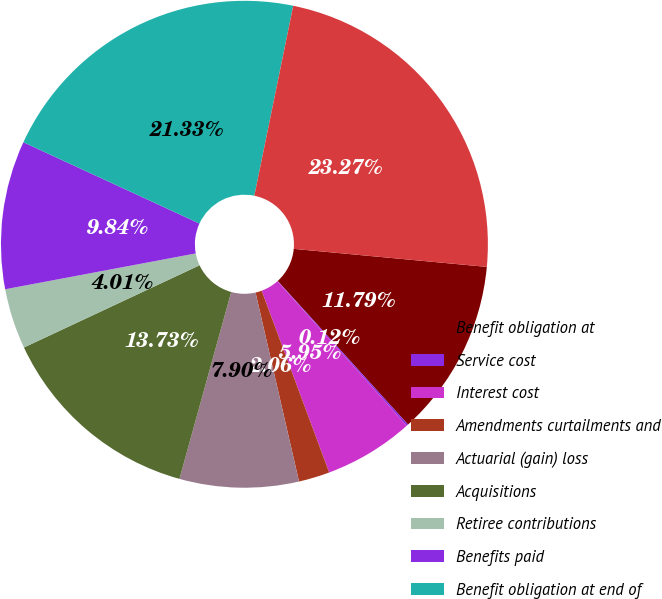Convert chart to OTSL. <chart><loc_0><loc_0><loc_500><loc_500><pie_chart><fcel>Benefit obligation at<fcel>Service cost<fcel>Interest cost<fcel>Amendments curtailments and<fcel>Actuarial (gain) loss<fcel>Acquisitions<fcel>Retiree contributions<fcel>Benefits paid<fcel>Benefit obligation at end of<fcel>Funded status/accrued benefit<nl><fcel>11.79%<fcel>0.12%<fcel>5.95%<fcel>2.06%<fcel>7.9%<fcel>13.73%<fcel>4.01%<fcel>9.84%<fcel>21.33%<fcel>23.27%<nl></chart> 